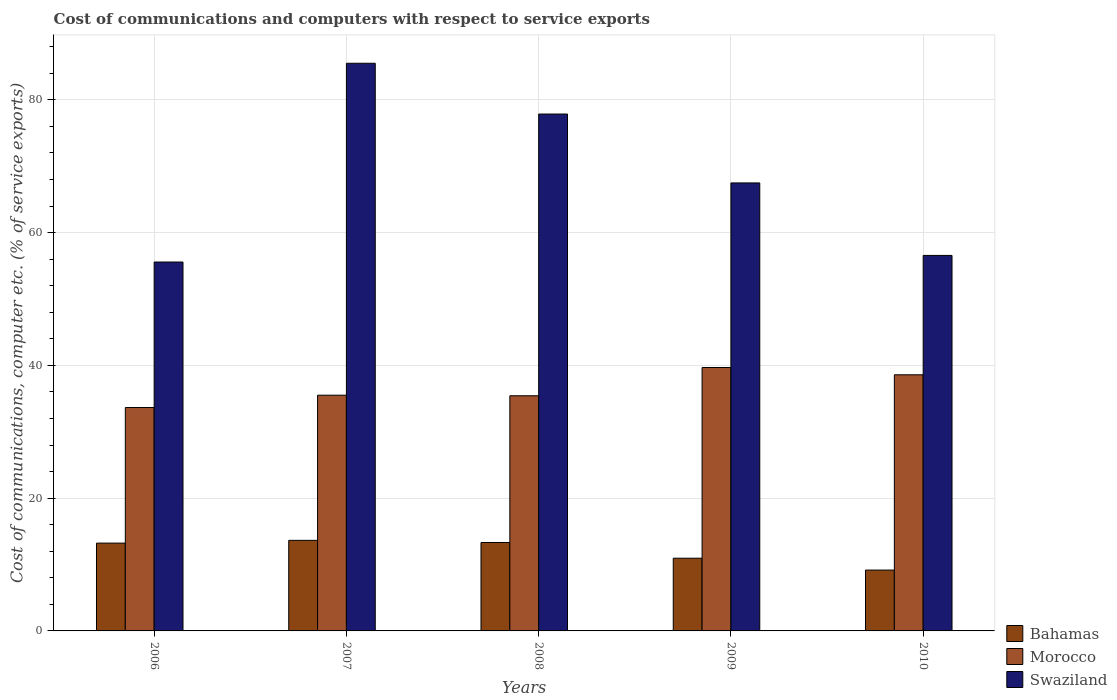Are the number of bars on each tick of the X-axis equal?
Your answer should be compact. Yes. How many bars are there on the 3rd tick from the left?
Make the answer very short. 3. What is the label of the 5th group of bars from the left?
Provide a succinct answer. 2010. What is the cost of communications and computers in Swaziland in 2008?
Make the answer very short. 77.86. Across all years, what is the maximum cost of communications and computers in Swaziland?
Offer a terse response. 85.51. Across all years, what is the minimum cost of communications and computers in Bahamas?
Keep it short and to the point. 9.17. What is the total cost of communications and computers in Morocco in the graph?
Your answer should be compact. 182.84. What is the difference between the cost of communications and computers in Bahamas in 2007 and that in 2008?
Offer a terse response. 0.32. What is the difference between the cost of communications and computers in Morocco in 2008 and the cost of communications and computers in Bahamas in 2009?
Keep it short and to the point. 24.47. What is the average cost of communications and computers in Bahamas per year?
Give a very brief answer. 12.06. In the year 2006, what is the difference between the cost of communications and computers in Bahamas and cost of communications and computers in Morocco?
Your answer should be very brief. -20.42. In how many years, is the cost of communications and computers in Morocco greater than 12 %?
Offer a very short reply. 5. What is the ratio of the cost of communications and computers in Morocco in 2006 to that in 2010?
Provide a succinct answer. 0.87. What is the difference between the highest and the second highest cost of communications and computers in Swaziland?
Provide a succinct answer. 7.65. What is the difference between the highest and the lowest cost of communications and computers in Swaziland?
Ensure brevity in your answer.  29.94. In how many years, is the cost of communications and computers in Swaziland greater than the average cost of communications and computers in Swaziland taken over all years?
Your answer should be very brief. 2. What does the 2nd bar from the left in 2006 represents?
Your answer should be very brief. Morocco. What does the 3rd bar from the right in 2008 represents?
Make the answer very short. Bahamas. Is it the case that in every year, the sum of the cost of communications and computers in Bahamas and cost of communications and computers in Morocco is greater than the cost of communications and computers in Swaziland?
Make the answer very short. No. How many bars are there?
Your response must be concise. 15. How many years are there in the graph?
Keep it short and to the point. 5. Where does the legend appear in the graph?
Your response must be concise. Bottom right. How are the legend labels stacked?
Your answer should be compact. Vertical. What is the title of the graph?
Offer a terse response. Cost of communications and computers with respect to service exports. Does "Kuwait" appear as one of the legend labels in the graph?
Provide a short and direct response. No. What is the label or title of the Y-axis?
Provide a short and direct response. Cost of communications, computer etc. (% of service exports). What is the Cost of communications, computer etc. (% of service exports) of Bahamas in 2006?
Offer a terse response. 13.23. What is the Cost of communications, computer etc. (% of service exports) of Morocco in 2006?
Ensure brevity in your answer.  33.65. What is the Cost of communications, computer etc. (% of service exports) of Swaziland in 2006?
Ensure brevity in your answer.  55.57. What is the Cost of communications, computer etc. (% of service exports) in Bahamas in 2007?
Make the answer very short. 13.64. What is the Cost of communications, computer etc. (% of service exports) in Morocco in 2007?
Your answer should be compact. 35.51. What is the Cost of communications, computer etc. (% of service exports) in Swaziland in 2007?
Make the answer very short. 85.51. What is the Cost of communications, computer etc. (% of service exports) of Bahamas in 2008?
Keep it short and to the point. 13.32. What is the Cost of communications, computer etc. (% of service exports) in Morocco in 2008?
Ensure brevity in your answer.  35.42. What is the Cost of communications, computer etc. (% of service exports) in Swaziland in 2008?
Offer a very short reply. 77.86. What is the Cost of communications, computer etc. (% of service exports) in Bahamas in 2009?
Offer a very short reply. 10.95. What is the Cost of communications, computer etc. (% of service exports) in Morocco in 2009?
Give a very brief answer. 39.68. What is the Cost of communications, computer etc. (% of service exports) in Swaziland in 2009?
Your answer should be compact. 67.48. What is the Cost of communications, computer etc. (% of service exports) of Bahamas in 2010?
Provide a short and direct response. 9.17. What is the Cost of communications, computer etc. (% of service exports) in Morocco in 2010?
Make the answer very short. 38.58. What is the Cost of communications, computer etc. (% of service exports) in Swaziland in 2010?
Give a very brief answer. 56.56. Across all years, what is the maximum Cost of communications, computer etc. (% of service exports) in Bahamas?
Provide a short and direct response. 13.64. Across all years, what is the maximum Cost of communications, computer etc. (% of service exports) of Morocco?
Ensure brevity in your answer.  39.68. Across all years, what is the maximum Cost of communications, computer etc. (% of service exports) of Swaziland?
Your answer should be very brief. 85.51. Across all years, what is the minimum Cost of communications, computer etc. (% of service exports) of Bahamas?
Offer a terse response. 9.17. Across all years, what is the minimum Cost of communications, computer etc. (% of service exports) of Morocco?
Keep it short and to the point. 33.65. Across all years, what is the minimum Cost of communications, computer etc. (% of service exports) in Swaziland?
Provide a succinct answer. 55.57. What is the total Cost of communications, computer etc. (% of service exports) of Bahamas in the graph?
Your response must be concise. 60.3. What is the total Cost of communications, computer etc. (% of service exports) of Morocco in the graph?
Make the answer very short. 182.84. What is the total Cost of communications, computer etc. (% of service exports) in Swaziland in the graph?
Provide a short and direct response. 342.98. What is the difference between the Cost of communications, computer etc. (% of service exports) in Bahamas in 2006 and that in 2007?
Your answer should be very brief. -0.41. What is the difference between the Cost of communications, computer etc. (% of service exports) in Morocco in 2006 and that in 2007?
Provide a short and direct response. -1.86. What is the difference between the Cost of communications, computer etc. (% of service exports) in Swaziland in 2006 and that in 2007?
Ensure brevity in your answer.  -29.94. What is the difference between the Cost of communications, computer etc. (% of service exports) in Bahamas in 2006 and that in 2008?
Offer a terse response. -0.09. What is the difference between the Cost of communications, computer etc. (% of service exports) in Morocco in 2006 and that in 2008?
Give a very brief answer. -1.77. What is the difference between the Cost of communications, computer etc. (% of service exports) in Swaziland in 2006 and that in 2008?
Offer a very short reply. -22.29. What is the difference between the Cost of communications, computer etc. (% of service exports) of Bahamas in 2006 and that in 2009?
Provide a succinct answer. 2.28. What is the difference between the Cost of communications, computer etc. (% of service exports) in Morocco in 2006 and that in 2009?
Offer a terse response. -6.03. What is the difference between the Cost of communications, computer etc. (% of service exports) in Swaziland in 2006 and that in 2009?
Your answer should be compact. -11.91. What is the difference between the Cost of communications, computer etc. (% of service exports) of Bahamas in 2006 and that in 2010?
Provide a succinct answer. 4.06. What is the difference between the Cost of communications, computer etc. (% of service exports) of Morocco in 2006 and that in 2010?
Give a very brief answer. -4.93. What is the difference between the Cost of communications, computer etc. (% of service exports) in Swaziland in 2006 and that in 2010?
Your answer should be very brief. -0.99. What is the difference between the Cost of communications, computer etc. (% of service exports) of Bahamas in 2007 and that in 2008?
Your answer should be compact. 0.32. What is the difference between the Cost of communications, computer etc. (% of service exports) of Morocco in 2007 and that in 2008?
Ensure brevity in your answer.  0.09. What is the difference between the Cost of communications, computer etc. (% of service exports) in Swaziland in 2007 and that in 2008?
Provide a succinct answer. 7.65. What is the difference between the Cost of communications, computer etc. (% of service exports) of Bahamas in 2007 and that in 2009?
Your response must be concise. 2.69. What is the difference between the Cost of communications, computer etc. (% of service exports) in Morocco in 2007 and that in 2009?
Your answer should be compact. -4.17. What is the difference between the Cost of communications, computer etc. (% of service exports) of Swaziland in 2007 and that in 2009?
Offer a very short reply. 18.03. What is the difference between the Cost of communications, computer etc. (% of service exports) of Bahamas in 2007 and that in 2010?
Ensure brevity in your answer.  4.48. What is the difference between the Cost of communications, computer etc. (% of service exports) in Morocco in 2007 and that in 2010?
Your response must be concise. -3.07. What is the difference between the Cost of communications, computer etc. (% of service exports) of Swaziland in 2007 and that in 2010?
Keep it short and to the point. 28.94. What is the difference between the Cost of communications, computer etc. (% of service exports) in Bahamas in 2008 and that in 2009?
Provide a short and direct response. 2.37. What is the difference between the Cost of communications, computer etc. (% of service exports) of Morocco in 2008 and that in 2009?
Give a very brief answer. -4.26. What is the difference between the Cost of communications, computer etc. (% of service exports) in Swaziland in 2008 and that in 2009?
Keep it short and to the point. 10.38. What is the difference between the Cost of communications, computer etc. (% of service exports) of Bahamas in 2008 and that in 2010?
Your answer should be very brief. 4.15. What is the difference between the Cost of communications, computer etc. (% of service exports) of Morocco in 2008 and that in 2010?
Your answer should be compact. -3.16. What is the difference between the Cost of communications, computer etc. (% of service exports) of Swaziland in 2008 and that in 2010?
Offer a terse response. 21.3. What is the difference between the Cost of communications, computer etc. (% of service exports) of Bahamas in 2009 and that in 2010?
Offer a terse response. 1.79. What is the difference between the Cost of communications, computer etc. (% of service exports) in Morocco in 2009 and that in 2010?
Provide a short and direct response. 1.1. What is the difference between the Cost of communications, computer etc. (% of service exports) in Swaziland in 2009 and that in 2010?
Keep it short and to the point. 10.92. What is the difference between the Cost of communications, computer etc. (% of service exports) in Bahamas in 2006 and the Cost of communications, computer etc. (% of service exports) in Morocco in 2007?
Keep it short and to the point. -22.28. What is the difference between the Cost of communications, computer etc. (% of service exports) in Bahamas in 2006 and the Cost of communications, computer etc. (% of service exports) in Swaziland in 2007?
Provide a succinct answer. -72.28. What is the difference between the Cost of communications, computer etc. (% of service exports) in Morocco in 2006 and the Cost of communications, computer etc. (% of service exports) in Swaziland in 2007?
Give a very brief answer. -51.86. What is the difference between the Cost of communications, computer etc. (% of service exports) in Bahamas in 2006 and the Cost of communications, computer etc. (% of service exports) in Morocco in 2008?
Ensure brevity in your answer.  -22.19. What is the difference between the Cost of communications, computer etc. (% of service exports) of Bahamas in 2006 and the Cost of communications, computer etc. (% of service exports) of Swaziland in 2008?
Offer a terse response. -64.63. What is the difference between the Cost of communications, computer etc. (% of service exports) in Morocco in 2006 and the Cost of communications, computer etc. (% of service exports) in Swaziland in 2008?
Your response must be concise. -44.21. What is the difference between the Cost of communications, computer etc. (% of service exports) of Bahamas in 2006 and the Cost of communications, computer etc. (% of service exports) of Morocco in 2009?
Give a very brief answer. -26.45. What is the difference between the Cost of communications, computer etc. (% of service exports) of Bahamas in 2006 and the Cost of communications, computer etc. (% of service exports) of Swaziland in 2009?
Offer a terse response. -54.26. What is the difference between the Cost of communications, computer etc. (% of service exports) of Morocco in 2006 and the Cost of communications, computer etc. (% of service exports) of Swaziland in 2009?
Your answer should be very brief. -33.83. What is the difference between the Cost of communications, computer etc. (% of service exports) in Bahamas in 2006 and the Cost of communications, computer etc. (% of service exports) in Morocco in 2010?
Provide a short and direct response. -25.35. What is the difference between the Cost of communications, computer etc. (% of service exports) of Bahamas in 2006 and the Cost of communications, computer etc. (% of service exports) of Swaziland in 2010?
Offer a terse response. -43.34. What is the difference between the Cost of communications, computer etc. (% of service exports) in Morocco in 2006 and the Cost of communications, computer etc. (% of service exports) in Swaziland in 2010?
Give a very brief answer. -22.91. What is the difference between the Cost of communications, computer etc. (% of service exports) in Bahamas in 2007 and the Cost of communications, computer etc. (% of service exports) in Morocco in 2008?
Your answer should be very brief. -21.78. What is the difference between the Cost of communications, computer etc. (% of service exports) in Bahamas in 2007 and the Cost of communications, computer etc. (% of service exports) in Swaziland in 2008?
Offer a terse response. -64.22. What is the difference between the Cost of communications, computer etc. (% of service exports) of Morocco in 2007 and the Cost of communications, computer etc. (% of service exports) of Swaziland in 2008?
Ensure brevity in your answer.  -42.35. What is the difference between the Cost of communications, computer etc. (% of service exports) in Bahamas in 2007 and the Cost of communications, computer etc. (% of service exports) in Morocco in 2009?
Your response must be concise. -26.04. What is the difference between the Cost of communications, computer etc. (% of service exports) of Bahamas in 2007 and the Cost of communications, computer etc. (% of service exports) of Swaziland in 2009?
Your response must be concise. -53.84. What is the difference between the Cost of communications, computer etc. (% of service exports) of Morocco in 2007 and the Cost of communications, computer etc. (% of service exports) of Swaziland in 2009?
Your answer should be compact. -31.98. What is the difference between the Cost of communications, computer etc. (% of service exports) of Bahamas in 2007 and the Cost of communications, computer etc. (% of service exports) of Morocco in 2010?
Your answer should be compact. -24.94. What is the difference between the Cost of communications, computer etc. (% of service exports) in Bahamas in 2007 and the Cost of communications, computer etc. (% of service exports) in Swaziland in 2010?
Offer a very short reply. -42.92. What is the difference between the Cost of communications, computer etc. (% of service exports) in Morocco in 2007 and the Cost of communications, computer etc. (% of service exports) in Swaziland in 2010?
Offer a very short reply. -21.06. What is the difference between the Cost of communications, computer etc. (% of service exports) in Bahamas in 2008 and the Cost of communications, computer etc. (% of service exports) in Morocco in 2009?
Make the answer very short. -26.36. What is the difference between the Cost of communications, computer etc. (% of service exports) in Bahamas in 2008 and the Cost of communications, computer etc. (% of service exports) in Swaziland in 2009?
Provide a succinct answer. -54.17. What is the difference between the Cost of communications, computer etc. (% of service exports) of Morocco in 2008 and the Cost of communications, computer etc. (% of service exports) of Swaziland in 2009?
Your response must be concise. -32.06. What is the difference between the Cost of communications, computer etc. (% of service exports) of Bahamas in 2008 and the Cost of communications, computer etc. (% of service exports) of Morocco in 2010?
Keep it short and to the point. -25.26. What is the difference between the Cost of communications, computer etc. (% of service exports) of Bahamas in 2008 and the Cost of communications, computer etc. (% of service exports) of Swaziland in 2010?
Offer a terse response. -43.25. What is the difference between the Cost of communications, computer etc. (% of service exports) of Morocco in 2008 and the Cost of communications, computer etc. (% of service exports) of Swaziland in 2010?
Your answer should be very brief. -21.14. What is the difference between the Cost of communications, computer etc. (% of service exports) of Bahamas in 2009 and the Cost of communications, computer etc. (% of service exports) of Morocco in 2010?
Ensure brevity in your answer.  -27.63. What is the difference between the Cost of communications, computer etc. (% of service exports) in Bahamas in 2009 and the Cost of communications, computer etc. (% of service exports) in Swaziland in 2010?
Offer a terse response. -45.61. What is the difference between the Cost of communications, computer etc. (% of service exports) in Morocco in 2009 and the Cost of communications, computer etc. (% of service exports) in Swaziland in 2010?
Offer a terse response. -16.89. What is the average Cost of communications, computer etc. (% of service exports) of Bahamas per year?
Give a very brief answer. 12.06. What is the average Cost of communications, computer etc. (% of service exports) of Morocco per year?
Make the answer very short. 36.57. What is the average Cost of communications, computer etc. (% of service exports) in Swaziland per year?
Provide a short and direct response. 68.6. In the year 2006, what is the difference between the Cost of communications, computer etc. (% of service exports) of Bahamas and Cost of communications, computer etc. (% of service exports) of Morocco?
Keep it short and to the point. -20.42. In the year 2006, what is the difference between the Cost of communications, computer etc. (% of service exports) of Bahamas and Cost of communications, computer etc. (% of service exports) of Swaziland?
Your answer should be compact. -42.34. In the year 2006, what is the difference between the Cost of communications, computer etc. (% of service exports) in Morocco and Cost of communications, computer etc. (% of service exports) in Swaziland?
Make the answer very short. -21.92. In the year 2007, what is the difference between the Cost of communications, computer etc. (% of service exports) in Bahamas and Cost of communications, computer etc. (% of service exports) in Morocco?
Your response must be concise. -21.87. In the year 2007, what is the difference between the Cost of communications, computer etc. (% of service exports) of Bahamas and Cost of communications, computer etc. (% of service exports) of Swaziland?
Ensure brevity in your answer.  -71.87. In the year 2007, what is the difference between the Cost of communications, computer etc. (% of service exports) in Morocco and Cost of communications, computer etc. (% of service exports) in Swaziland?
Your answer should be very brief. -50. In the year 2008, what is the difference between the Cost of communications, computer etc. (% of service exports) of Bahamas and Cost of communications, computer etc. (% of service exports) of Morocco?
Provide a succinct answer. -22.1. In the year 2008, what is the difference between the Cost of communications, computer etc. (% of service exports) of Bahamas and Cost of communications, computer etc. (% of service exports) of Swaziland?
Your answer should be very brief. -64.54. In the year 2008, what is the difference between the Cost of communications, computer etc. (% of service exports) of Morocco and Cost of communications, computer etc. (% of service exports) of Swaziland?
Provide a short and direct response. -42.44. In the year 2009, what is the difference between the Cost of communications, computer etc. (% of service exports) of Bahamas and Cost of communications, computer etc. (% of service exports) of Morocco?
Offer a terse response. -28.73. In the year 2009, what is the difference between the Cost of communications, computer etc. (% of service exports) of Bahamas and Cost of communications, computer etc. (% of service exports) of Swaziland?
Your answer should be very brief. -56.53. In the year 2009, what is the difference between the Cost of communications, computer etc. (% of service exports) in Morocco and Cost of communications, computer etc. (% of service exports) in Swaziland?
Your answer should be very brief. -27.81. In the year 2010, what is the difference between the Cost of communications, computer etc. (% of service exports) of Bahamas and Cost of communications, computer etc. (% of service exports) of Morocco?
Make the answer very short. -29.42. In the year 2010, what is the difference between the Cost of communications, computer etc. (% of service exports) in Bahamas and Cost of communications, computer etc. (% of service exports) in Swaziland?
Ensure brevity in your answer.  -47.4. In the year 2010, what is the difference between the Cost of communications, computer etc. (% of service exports) of Morocco and Cost of communications, computer etc. (% of service exports) of Swaziland?
Provide a succinct answer. -17.98. What is the ratio of the Cost of communications, computer etc. (% of service exports) of Bahamas in 2006 to that in 2007?
Ensure brevity in your answer.  0.97. What is the ratio of the Cost of communications, computer etc. (% of service exports) in Morocco in 2006 to that in 2007?
Give a very brief answer. 0.95. What is the ratio of the Cost of communications, computer etc. (% of service exports) in Swaziland in 2006 to that in 2007?
Provide a short and direct response. 0.65. What is the ratio of the Cost of communications, computer etc. (% of service exports) in Bahamas in 2006 to that in 2008?
Your answer should be very brief. 0.99. What is the ratio of the Cost of communications, computer etc. (% of service exports) of Morocco in 2006 to that in 2008?
Make the answer very short. 0.95. What is the ratio of the Cost of communications, computer etc. (% of service exports) of Swaziland in 2006 to that in 2008?
Provide a succinct answer. 0.71. What is the ratio of the Cost of communications, computer etc. (% of service exports) of Bahamas in 2006 to that in 2009?
Keep it short and to the point. 1.21. What is the ratio of the Cost of communications, computer etc. (% of service exports) in Morocco in 2006 to that in 2009?
Offer a terse response. 0.85. What is the ratio of the Cost of communications, computer etc. (% of service exports) of Swaziland in 2006 to that in 2009?
Offer a very short reply. 0.82. What is the ratio of the Cost of communications, computer etc. (% of service exports) in Bahamas in 2006 to that in 2010?
Keep it short and to the point. 1.44. What is the ratio of the Cost of communications, computer etc. (% of service exports) of Morocco in 2006 to that in 2010?
Make the answer very short. 0.87. What is the ratio of the Cost of communications, computer etc. (% of service exports) in Swaziland in 2006 to that in 2010?
Offer a very short reply. 0.98. What is the ratio of the Cost of communications, computer etc. (% of service exports) in Bahamas in 2007 to that in 2008?
Your response must be concise. 1.02. What is the ratio of the Cost of communications, computer etc. (% of service exports) in Morocco in 2007 to that in 2008?
Give a very brief answer. 1. What is the ratio of the Cost of communications, computer etc. (% of service exports) of Swaziland in 2007 to that in 2008?
Your response must be concise. 1.1. What is the ratio of the Cost of communications, computer etc. (% of service exports) of Bahamas in 2007 to that in 2009?
Offer a very short reply. 1.25. What is the ratio of the Cost of communications, computer etc. (% of service exports) of Morocco in 2007 to that in 2009?
Ensure brevity in your answer.  0.89. What is the ratio of the Cost of communications, computer etc. (% of service exports) of Swaziland in 2007 to that in 2009?
Offer a very short reply. 1.27. What is the ratio of the Cost of communications, computer etc. (% of service exports) in Bahamas in 2007 to that in 2010?
Provide a short and direct response. 1.49. What is the ratio of the Cost of communications, computer etc. (% of service exports) of Morocco in 2007 to that in 2010?
Your response must be concise. 0.92. What is the ratio of the Cost of communications, computer etc. (% of service exports) of Swaziland in 2007 to that in 2010?
Keep it short and to the point. 1.51. What is the ratio of the Cost of communications, computer etc. (% of service exports) in Bahamas in 2008 to that in 2009?
Your answer should be compact. 1.22. What is the ratio of the Cost of communications, computer etc. (% of service exports) of Morocco in 2008 to that in 2009?
Make the answer very short. 0.89. What is the ratio of the Cost of communications, computer etc. (% of service exports) in Swaziland in 2008 to that in 2009?
Ensure brevity in your answer.  1.15. What is the ratio of the Cost of communications, computer etc. (% of service exports) in Bahamas in 2008 to that in 2010?
Ensure brevity in your answer.  1.45. What is the ratio of the Cost of communications, computer etc. (% of service exports) in Morocco in 2008 to that in 2010?
Ensure brevity in your answer.  0.92. What is the ratio of the Cost of communications, computer etc. (% of service exports) of Swaziland in 2008 to that in 2010?
Your response must be concise. 1.38. What is the ratio of the Cost of communications, computer etc. (% of service exports) in Bahamas in 2009 to that in 2010?
Provide a succinct answer. 1.19. What is the ratio of the Cost of communications, computer etc. (% of service exports) in Morocco in 2009 to that in 2010?
Offer a terse response. 1.03. What is the ratio of the Cost of communications, computer etc. (% of service exports) of Swaziland in 2009 to that in 2010?
Your answer should be compact. 1.19. What is the difference between the highest and the second highest Cost of communications, computer etc. (% of service exports) in Bahamas?
Give a very brief answer. 0.32. What is the difference between the highest and the second highest Cost of communications, computer etc. (% of service exports) in Morocco?
Your response must be concise. 1.1. What is the difference between the highest and the second highest Cost of communications, computer etc. (% of service exports) in Swaziland?
Ensure brevity in your answer.  7.65. What is the difference between the highest and the lowest Cost of communications, computer etc. (% of service exports) in Bahamas?
Offer a very short reply. 4.48. What is the difference between the highest and the lowest Cost of communications, computer etc. (% of service exports) in Morocco?
Your answer should be very brief. 6.03. What is the difference between the highest and the lowest Cost of communications, computer etc. (% of service exports) of Swaziland?
Provide a short and direct response. 29.94. 